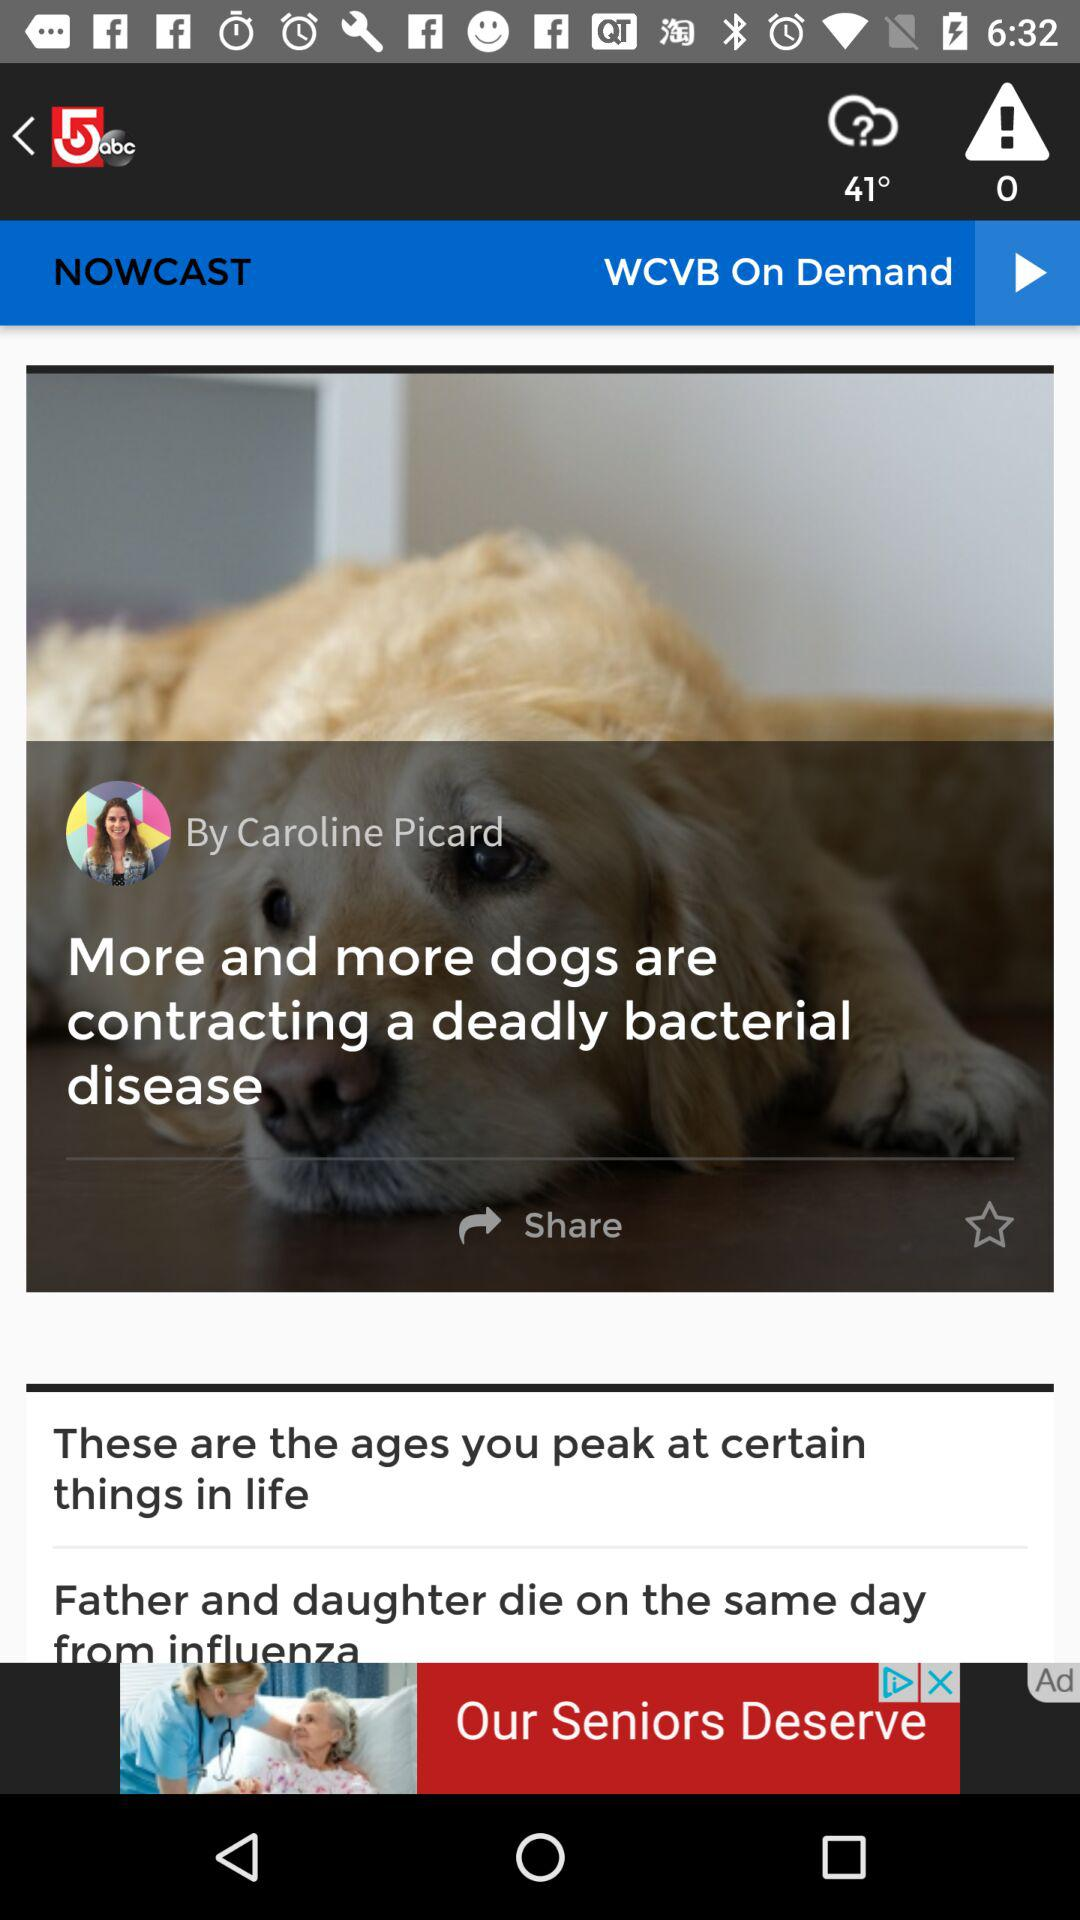What is the name of the disease by which the father and daughter died? The name of the disease is influenza. 